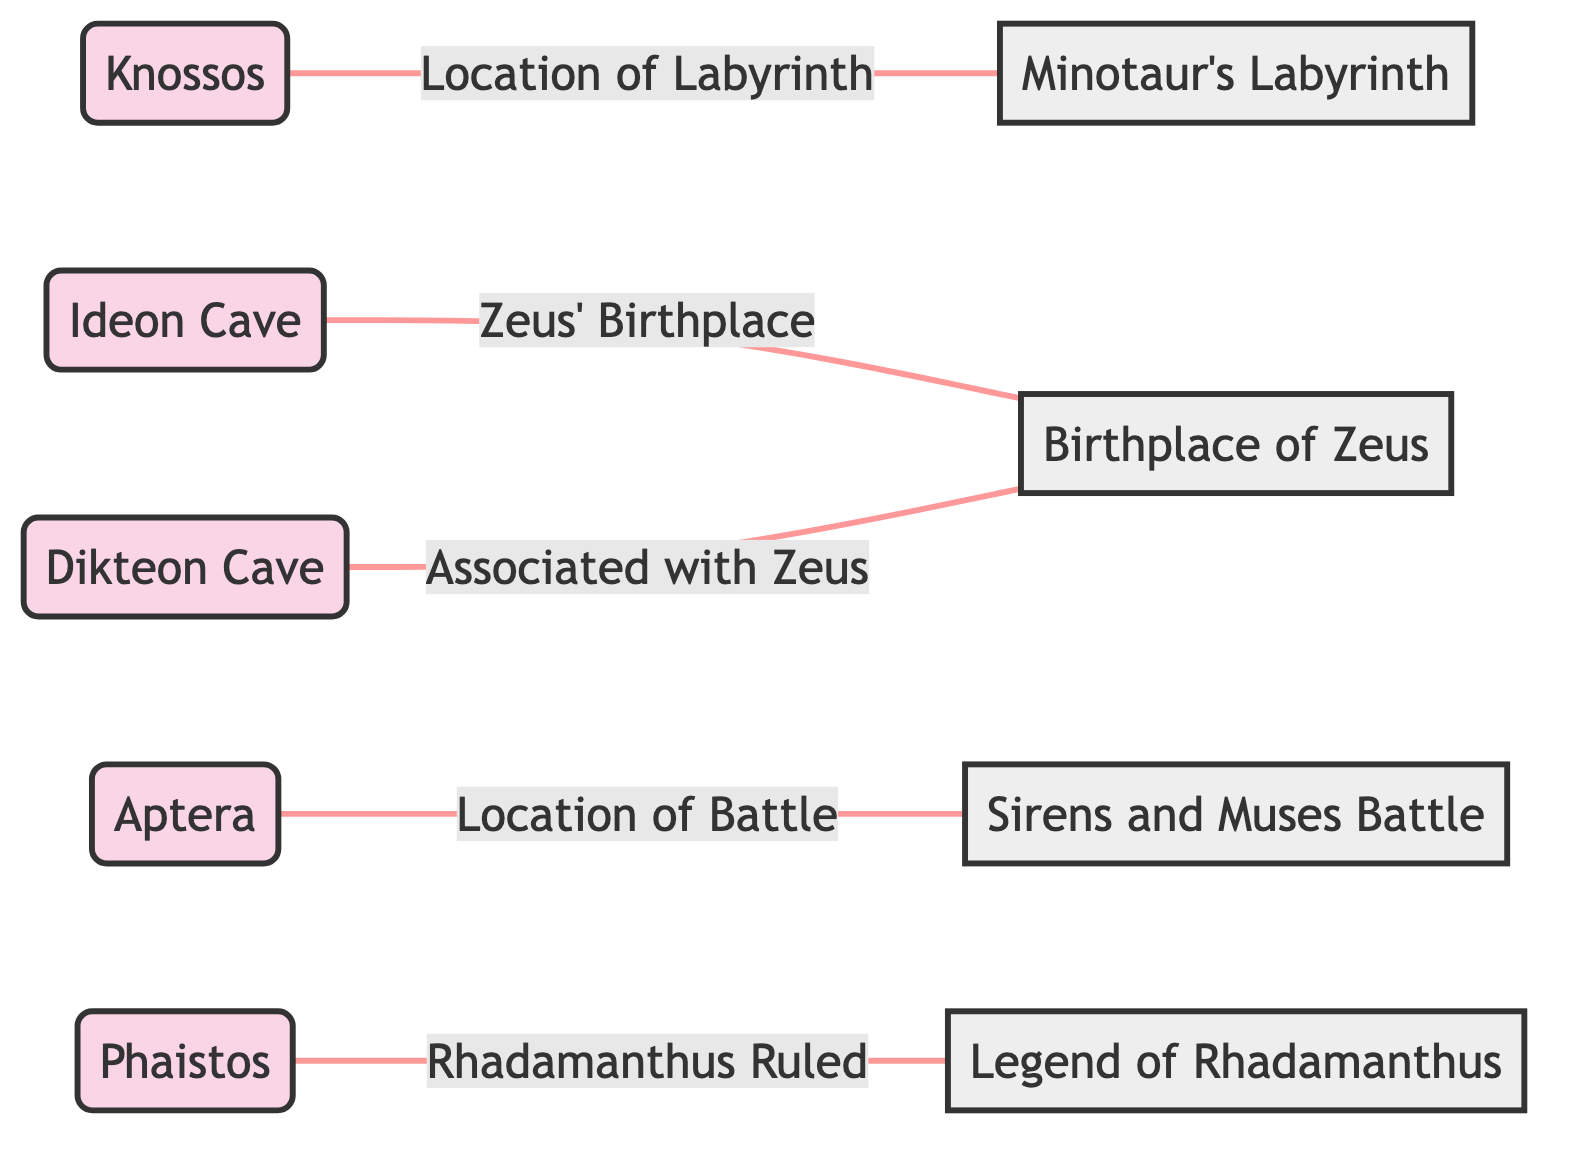What are the two caves associated with the birthplace of Zeus? The diagram indicates that both Ideon Cave and Dikteon Cave are linked to the Birthplace of Zeus, as shown by the edges connecting these locations.
Answer: Ideon Cave, Dikteon Cave How many locations are represented in the diagram? By counting the node entries labeled as locations, we see that there are five distinct locations: Knossos, Ideon Cave, Dikteon Cave, Aptera, and Phaistos.
Answer: 5 Which landmark is linked to the Minotaur's Labyrinth? The edge connecting Knossos to the Minotaur's Labyrinth specifies that Knossos is the location of the Labyrinth, indicating a direct relationship.
Answer: Knossos What battle is associated with the location of Aptera? The diagram connects Aptera directly to the Sirens and Muses Battle, indicating that Aptera is the location where this battle occurred.
Answer: Sirens and Muses Battle Which legend is connected to the location Phaistos? The edge from Phaistos to the Legend of Rhadamanthus indicates that Phaistos is where Rhadamanthus ruled, making it the specific legend tied to that location.
Answer: Legend of Rhadamanthus Which two locations are related to Zeus? The directed edges indicate that both Ideon Cave and Dikteon Cave have a connection to the Birthplace of Zeus, reflecting multiple sites associated with Zeus.
Answer: Ideon Cave, Dikteon Cave What is the relationship between Knossos and the Minotaur's Labyrinth? The diagram indicates that Knossos is the location of the Labyrinth, making it the point where the Minotaur's story unfolds, as specified by the edge connection.
Answer: Location of Labyrinth What geographical feature does Aptera represent? According to the diagram, Aptera is identified as a location, specifically linked to a significant mythological event, namely the battle between the Sirens and the Muses.
Answer: Location 